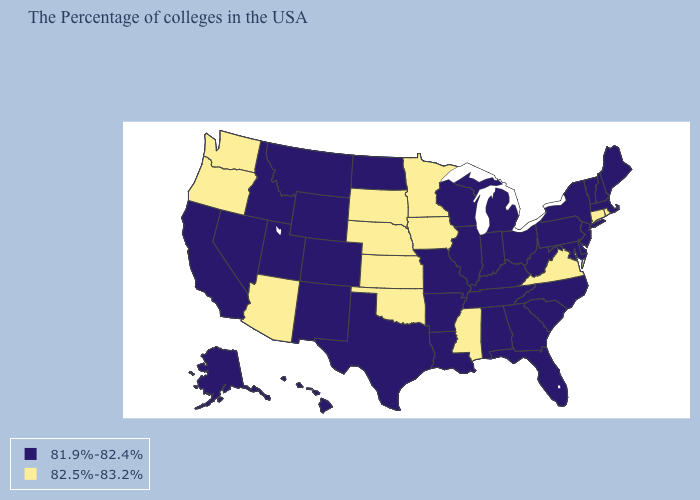Name the states that have a value in the range 82.5%-83.2%?
Be succinct. Rhode Island, Connecticut, Virginia, Mississippi, Minnesota, Iowa, Kansas, Nebraska, Oklahoma, South Dakota, Arizona, Washington, Oregon. Among the states that border Idaho , does Washington have the highest value?
Short answer required. Yes. Name the states that have a value in the range 81.9%-82.4%?
Short answer required. Maine, Massachusetts, New Hampshire, Vermont, New York, New Jersey, Delaware, Maryland, Pennsylvania, North Carolina, South Carolina, West Virginia, Ohio, Florida, Georgia, Michigan, Kentucky, Indiana, Alabama, Tennessee, Wisconsin, Illinois, Louisiana, Missouri, Arkansas, Texas, North Dakota, Wyoming, Colorado, New Mexico, Utah, Montana, Idaho, Nevada, California, Alaska, Hawaii. Name the states that have a value in the range 82.5%-83.2%?
Short answer required. Rhode Island, Connecticut, Virginia, Mississippi, Minnesota, Iowa, Kansas, Nebraska, Oklahoma, South Dakota, Arizona, Washington, Oregon. Among the states that border Oklahoma , does Colorado have the highest value?
Answer briefly. No. Which states have the highest value in the USA?
Concise answer only. Rhode Island, Connecticut, Virginia, Mississippi, Minnesota, Iowa, Kansas, Nebraska, Oklahoma, South Dakota, Arizona, Washington, Oregon. What is the value of Rhode Island?
Short answer required. 82.5%-83.2%. Among the states that border Ohio , which have the lowest value?
Write a very short answer. Pennsylvania, West Virginia, Michigan, Kentucky, Indiana. Does Washington have the highest value in the West?
Keep it brief. Yes. What is the highest value in the USA?
Keep it brief. 82.5%-83.2%. Name the states that have a value in the range 82.5%-83.2%?
Quick response, please. Rhode Island, Connecticut, Virginia, Mississippi, Minnesota, Iowa, Kansas, Nebraska, Oklahoma, South Dakota, Arizona, Washington, Oregon. Which states have the lowest value in the USA?
Give a very brief answer. Maine, Massachusetts, New Hampshire, Vermont, New York, New Jersey, Delaware, Maryland, Pennsylvania, North Carolina, South Carolina, West Virginia, Ohio, Florida, Georgia, Michigan, Kentucky, Indiana, Alabama, Tennessee, Wisconsin, Illinois, Louisiana, Missouri, Arkansas, Texas, North Dakota, Wyoming, Colorado, New Mexico, Utah, Montana, Idaho, Nevada, California, Alaska, Hawaii. Does the map have missing data?
Give a very brief answer. No. Does Oklahoma have the lowest value in the South?
Give a very brief answer. No. 